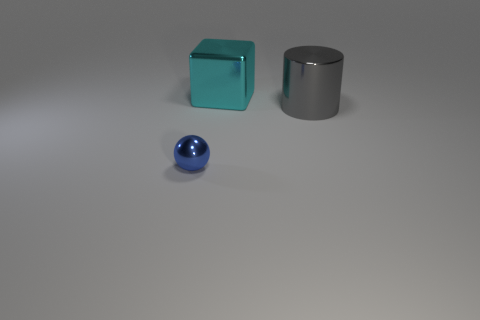Add 2 small blue things. How many objects exist? 5 Subtract all spheres. How many objects are left? 2 Add 1 big cyan metallic objects. How many big cyan metallic objects are left? 2 Add 2 small brown matte objects. How many small brown matte objects exist? 2 Subtract 0 purple spheres. How many objects are left? 3 Subtract all big cubes. Subtract all cubes. How many objects are left? 1 